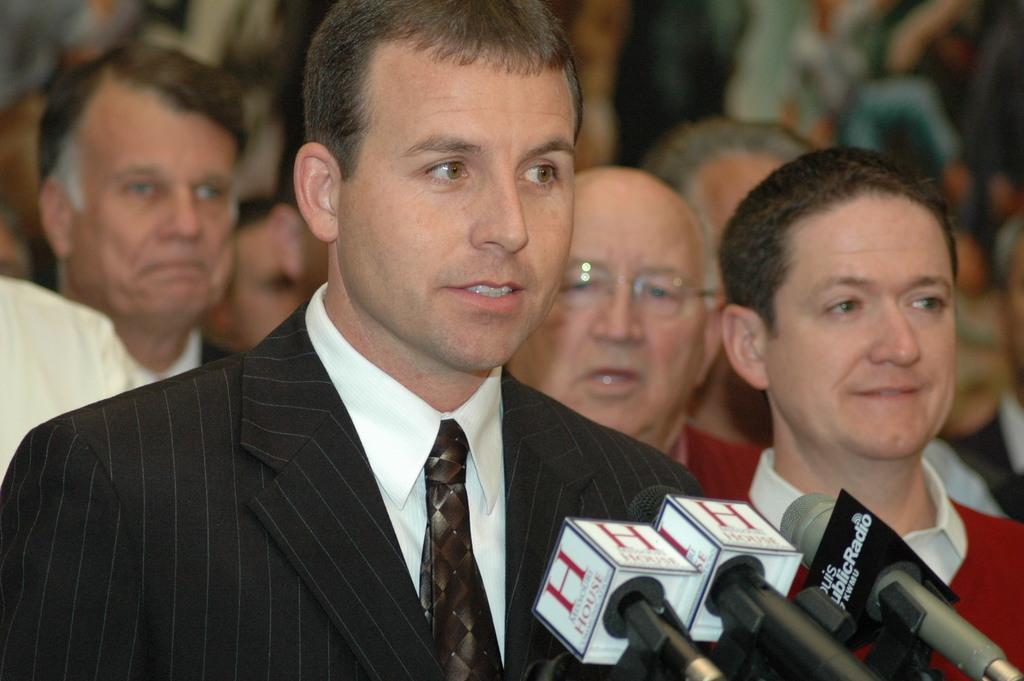Describe this image in one or two sentences. In this image there is a person he is wearing white shirt black coat and a tie, in front of him there are mice, in the background people are standing. 